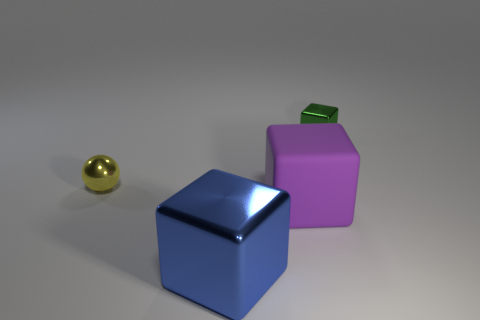Is there anything else that has the same material as the purple block?
Keep it short and to the point. No. Is there a purple metallic object of the same shape as the green thing?
Offer a terse response. No. How many other things are there of the same color as the ball?
Make the answer very short. 0. There is a small thing to the left of the metallic block that is in front of the small shiny object that is left of the blue object; what is its color?
Provide a short and direct response. Yellow. Is the number of big rubber cubes on the left side of the big purple matte cube the same as the number of purple rubber blocks?
Your response must be concise. No. Is the size of the metal cube in front of the yellow thing the same as the tiny shiny block?
Provide a succinct answer. No. What number of large things are there?
Provide a short and direct response. 2. How many objects are left of the big blue metallic thing and behind the ball?
Make the answer very short. 0. Are there any yellow objects that have the same material as the purple object?
Your answer should be compact. No. There is a small thing right of the metal object on the left side of the large metallic thing; what is its material?
Your answer should be compact. Metal. 